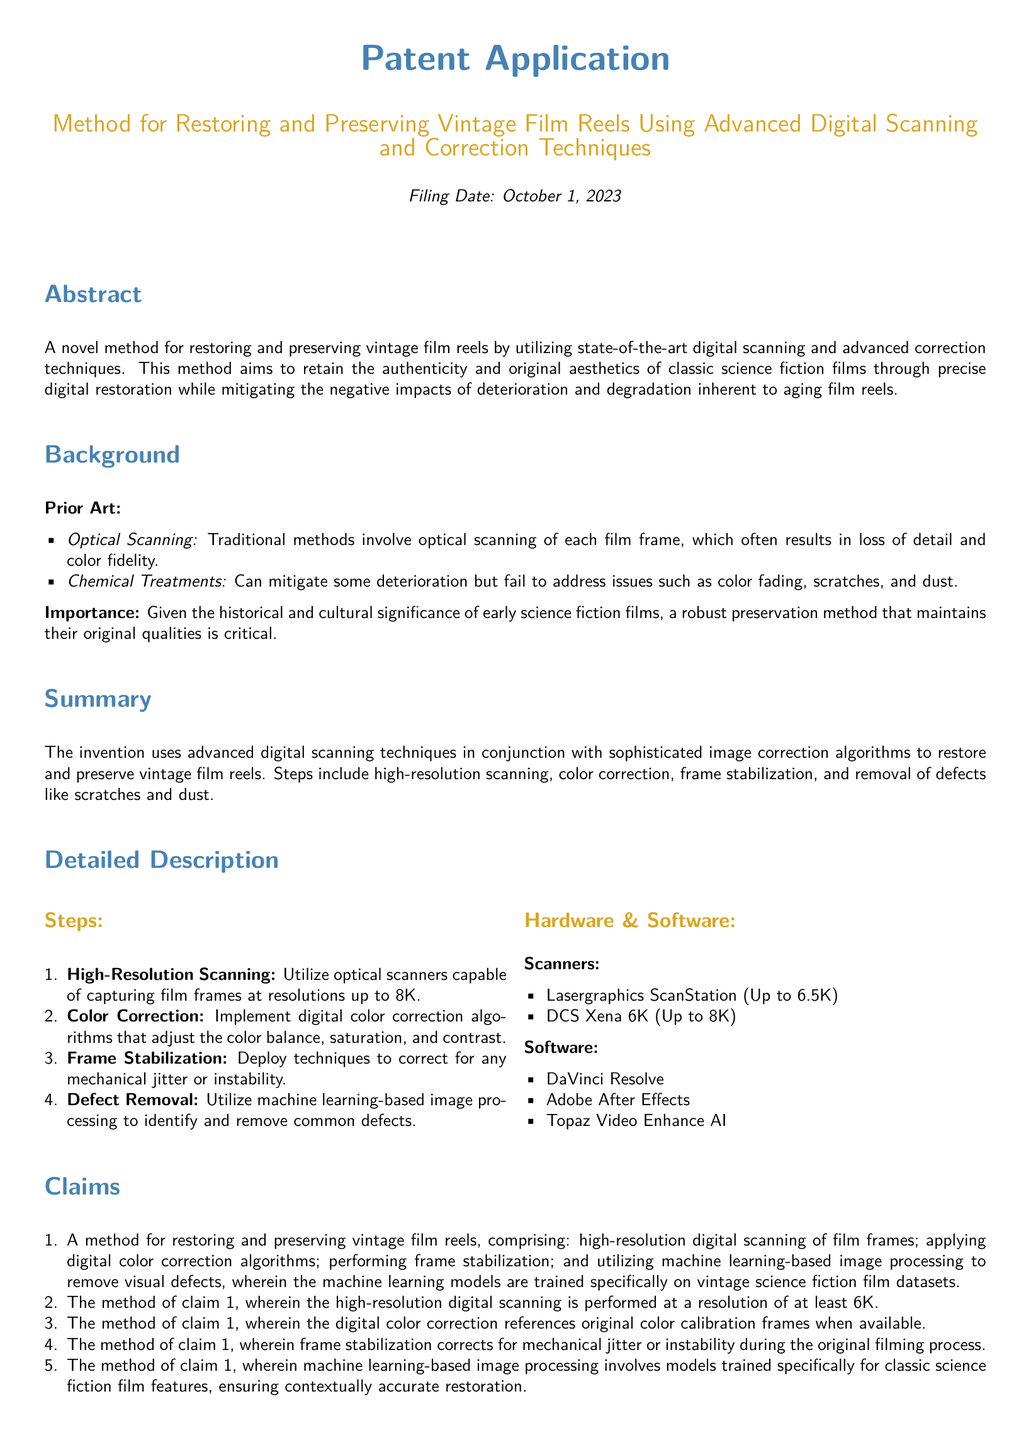What is the filing date? The filing date is explicitly stated in the document as October 1, 2023.
Answer: October 1, 2023 What are the names of the inventors? The document provides a list of inventors including John Doe and Jane Smith.
Answer: John Doe, Jane Smith What is the maximum resolution for high-resolution scanning mentioned? The document mentions that high-resolution scanning utilizes resolutions up to 8K.
Answer: 8K What type of software is mentioned in the document? The document lists several software tools, such as DaVinci Resolve and Adobe After Effects.
Answer: DaVinci Resolve, Adobe After Effects Why is the preservation method considered important? The importance is highlighted in the document as it relates to the historical and cultural significance of early science fiction films.
Answer: Historical and cultural significance What technique is employed to remove visual defects? The document states that machine learning-based image processing is used to identify and remove defects.
Answer: Machine learning-based image processing What feature is being stabilized in this restoration process? Frame stabilization is specifically mentioned for correcting mechanical jitter or instability during filming.
Answer: Mechanical jitter or instability How does the document classify its content? The structure of the document includes sections like Abstract, Background, Summary, and Claims, typical of a patent application.
Answer: Patent application What kind of scanning technology is used according to the document? The document specifies optical scanners such as Lasergraphics ScanStation for scanning film frames.
Answer: Optical scanners 